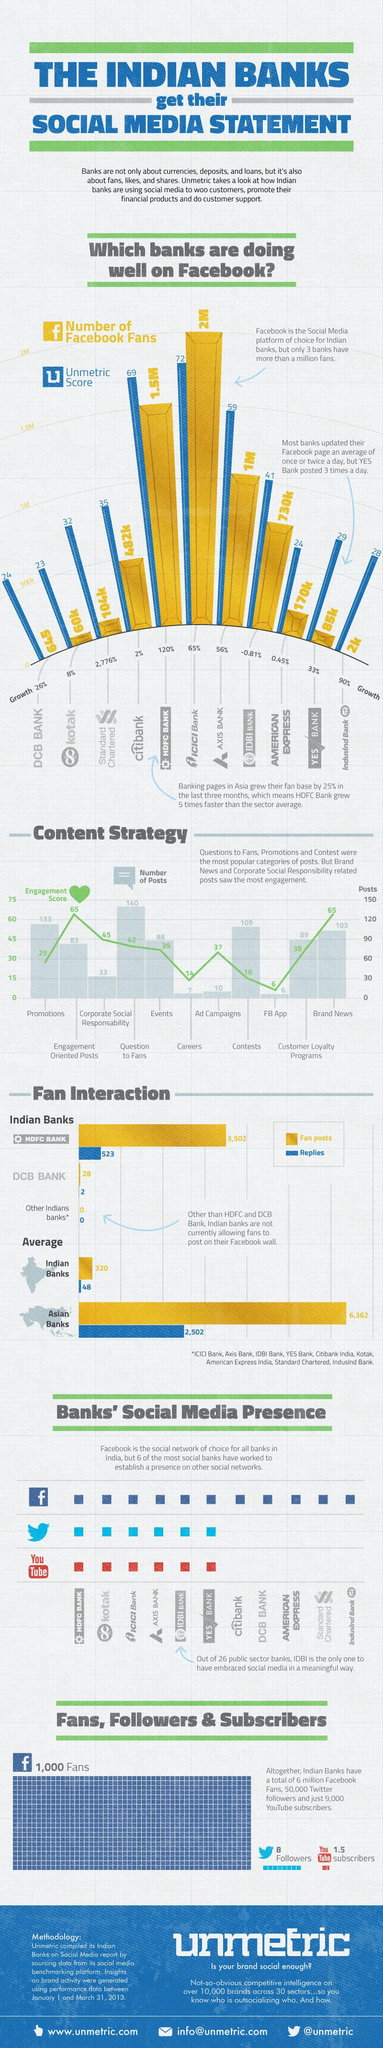Highlight a few significant elements in this photo. There are four contents that have more than 100 posts. HDFC bank, ICICI bank, and Axis bank are all banks that have more than 1 million fans on Facebook. Of the contents we have, which have an engagement score of greater than 50, there are 2 of them. 